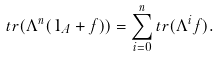Convert formula to latex. <formula><loc_0><loc_0><loc_500><loc_500>t r ( \Lambda ^ { n } ( 1 _ { A } + f ) ) = \sum _ { i = 0 } ^ { n } t r ( \Lambda ^ { i } f ) .</formula> 